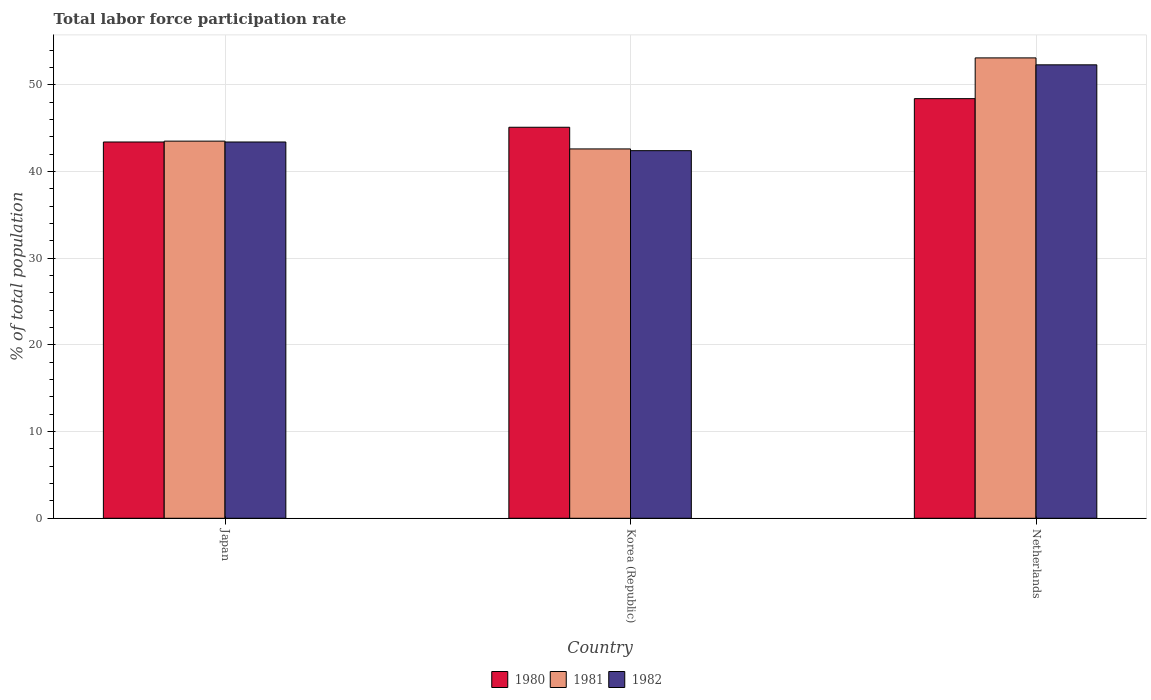How many groups of bars are there?
Your answer should be very brief. 3. Are the number of bars on each tick of the X-axis equal?
Offer a terse response. Yes. What is the label of the 3rd group of bars from the left?
Make the answer very short. Netherlands. In how many cases, is the number of bars for a given country not equal to the number of legend labels?
Your answer should be very brief. 0. What is the total labor force participation rate in 1980 in Netherlands?
Provide a short and direct response. 48.4. Across all countries, what is the maximum total labor force participation rate in 1980?
Your response must be concise. 48.4. Across all countries, what is the minimum total labor force participation rate in 1980?
Make the answer very short. 43.4. In which country was the total labor force participation rate in 1981 minimum?
Your response must be concise. Korea (Republic). What is the total total labor force participation rate in 1980 in the graph?
Your answer should be compact. 136.9. What is the difference between the total labor force participation rate in 1981 in Japan and that in Korea (Republic)?
Ensure brevity in your answer.  0.9. What is the difference between the total labor force participation rate in 1980 in Netherlands and the total labor force participation rate in 1982 in Korea (Republic)?
Offer a terse response. 6. What is the average total labor force participation rate in 1980 per country?
Your answer should be very brief. 45.63. What is the difference between the total labor force participation rate of/in 1981 and total labor force participation rate of/in 1980 in Netherlands?
Offer a very short reply. 4.7. In how many countries, is the total labor force participation rate in 1980 greater than 8 %?
Offer a terse response. 3. What is the ratio of the total labor force participation rate in 1982 in Japan to that in Korea (Republic)?
Your response must be concise. 1.02. What is the difference between the highest and the second highest total labor force participation rate in 1981?
Offer a terse response. -0.9. What is the difference between the highest and the lowest total labor force participation rate in 1982?
Provide a short and direct response. 9.9. In how many countries, is the total labor force participation rate in 1980 greater than the average total labor force participation rate in 1980 taken over all countries?
Offer a very short reply. 1. Is the sum of the total labor force participation rate in 1982 in Japan and Korea (Republic) greater than the maximum total labor force participation rate in 1980 across all countries?
Provide a succinct answer. Yes. What does the 1st bar from the left in Netherlands represents?
Provide a short and direct response. 1980. Is it the case that in every country, the sum of the total labor force participation rate in 1982 and total labor force participation rate in 1980 is greater than the total labor force participation rate in 1981?
Offer a very short reply. Yes. How many countries are there in the graph?
Offer a terse response. 3. Are the values on the major ticks of Y-axis written in scientific E-notation?
Give a very brief answer. No. How many legend labels are there?
Keep it short and to the point. 3. What is the title of the graph?
Your answer should be compact. Total labor force participation rate. What is the label or title of the Y-axis?
Offer a terse response. % of total population. What is the % of total population of 1980 in Japan?
Keep it short and to the point. 43.4. What is the % of total population in 1981 in Japan?
Your answer should be compact. 43.5. What is the % of total population in 1982 in Japan?
Offer a terse response. 43.4. What is the % of total population of 1980 in Korea (Republic)?
Make the answer very short. 45.1. What is the % of total population of 1981 in Korea (Republic)?
Keep it short and to the point. 42.6. What is the % of total population in 1982 in Korea (Republic)?
Provide a succinct answer. 42.4. What is the % of total population of 1980 in Netherlands?
Your answer should be very brief. 48.4. What is the % of total population of 1981 in Netherlands?
Offer a very short reply. 53.1. What is the % of total population of 1982 in Netherlands?
Provide a succinct answer. 52.3. Across all countries, what is the maximum % of total population of 1980?
Provide a short and direct response. 48.4. Across all countries, what is the maximum % of total population in 1981?
Make the answer very short. 53.1. Across all countries, what is the maximum % of total population of 1982?
Provide a short and direct response. 52.3. Across all countries, what is the minimum % of total population of 1980?
Your answer should be compact. 43.4. Across all countries, what is the minimum % of total population in 1981?
Make the answer very short. 42.6. Across all countries, what is the minimum % of total population of 1982?
Keep it short and to the point. 42.4. What is the total % of total population of 1980 in the graph?
Your answer should be compact. 136.9. What is the total % of total population of 1981 in the graph?
Make the answer very short. 139.2. What is the total % of total population of 1982 in the graph?
Offer a terse response. 138.1. What is the difference between the % of total population of 1982 in Japan and that in Netherlands?
Provide a short and direct response. -8.9. What is the difference between the % of total population in 1981 in Korea (Republic) and that in Netherlands?
Offer a terse response. -10.5. What is the difference between the % of total population of 1980 in Japan and the % of total population of 1981 in Korea (Republic)?
Your answer should be very brief. 0.8. What is the difference between the % of total population of 1980 in Japan and the % of total population of 1982 in Korea (Republic)?
Ensure brevity in your answer.  1. What is the difference between the % of total population of 1981 in Japan and the % of total population of 1982 in Korea (Republic)?
Your response must be concise. 1.1. What is the difference between the % of total population in 1980 in Japan and the % of total population in 1981 in Netherlands?
Keep it short and to the point. -9.7. What is the difference between the % of total population in 1980 in Japan and the % of total population in 1982 in Netherlands?
Offer a very short reply. -8.9. What is the average % of total population in 1980 per country?
Ensure brevity in your answer.  45.63. What is the average % of total population in 1981 per country?
Give a very brief answer. 46.4. What is the average % of total population of 1982 per country?
Offer a terse response. 46.03. What is the difference between the % of total population of 1980 and % of total population of 1981 in Japan?
Your response must be concise. -0.1. What is the difference between the % of total population of 1981 and % of total population of 1982 in Japan?
Provide a succinct answer. 0.1. What is the difference between the % of total population in 1980 and % of total population in 1981 in Korea (Republic)?
Provide a short and direct response. 2.5. What is the difference between the % of total population of 1980 and % of total population of 1981 in Netherlands?
Your answer should be compact. -4.7. What is the difference between the % of total population in 1980 and % of total population in 1982 in Netherlands?
Your answer should be compact. -3.9. What is the ratio of the % of total population in 1980 in Japan to that in Korea (Republic)?
Your answer should be compact. 0.96. What is the ratio of the % of total population in 1981 in Japan to that in Korea (Republic)?
Provide a short and direct response. 1.02. What is the ratio of the % of total population of 1982 in Japan to that in Korea (Republic)?
Offer a terse response. 1.02. What is the ratio of the % of total population of 1980 in Japan to that in Netherlands?
Your answer should be very brief. 0.9. What is the ratio of the % of total population in 1981 in Japan to that in Netherlands?
Your answer should be compact. 0.82. What is the ratio of the % of total population in 1982 in Japan to that in Netherlands?
Make the answer very short. 0.83. What is the ratio of the % of total population of 1980 in Korea (Republic) to that in Netherlands?
Your response must be concise. 0.93. What is the ratio of the % of total population of 1981 in Korea (Republic) to that in Netherlands?
Ensure brevity in your answer.  0.8. What is the ratio of the % of total population in 1982 in Korea (Republic) to that in Netherlands?
Provide a short and direct response. 0.81. What is the difference between the highest and the lowest % of total population of 1981?
Provide a succinct answer. 10.5. 